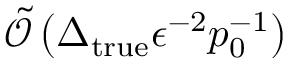Convert formula to latex. <formula><loc_0><loc_0><loc_500><loc_500>\tilde { \mathcal { O } } \left ( \Delta _ { t r u e } \epsilon ^ { - 2 } p _ { 0 } ^ { - 1 } \right )</formula> 